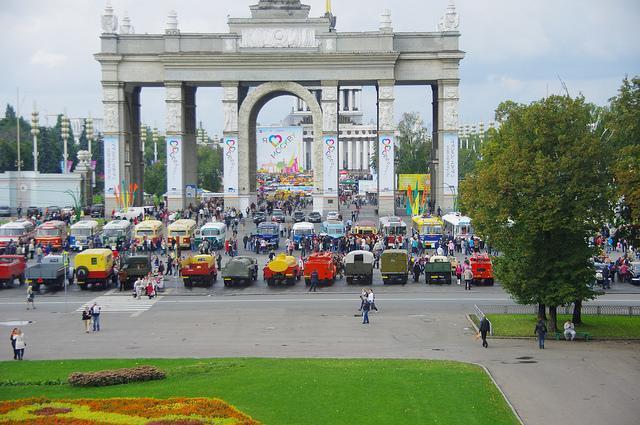The signs are expressing their love for which city?
Choose the correct response and explain in the format: 'Answer: answer
Rationale: rationale.'
Options: Manchester, moscow, milan, manila. Answer: moscow.
Rationale: The signs are for moscow. 